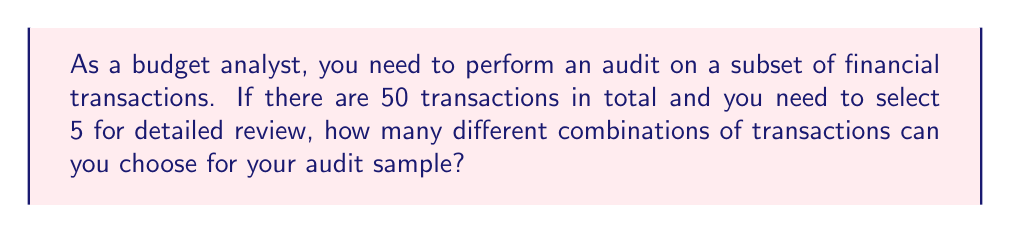Solve this math problem. To solve this problem, we need to use the combination formula. This is because the order of selection doesn't matter (it's not a permutation), and we're selecting a subset from a larger set without replacement.

The combination formula is:

$$C(n,r) = \frac{n!}{r!(n-r)!}$$

Where:
$n$ = total number of items to choose from
$r$ = number of items being chosen

In this case:
$n = 50$ (total transactions)
$r = 5$ (transactions to be audited)

Let's substitute these values:

$$C(50,5) = \frac{50!}{5!(50-5)!} = \frac{50!}{5!45!}$$

Calculating this:

1) $50! = 3.0414 \times 10^{64}$
2) $5! = 120$
3) $45! = 1.1962 \times 10^{56}$

Substituting:

$$\frac{3.0414 \times 10^{64}}{120 \times (1.1962 \times 10^{56})} = 2,118,760$$

Therefore, there are 2,118,760 different possible combinations of 5 transactions that can be selected from a total of 50 transactions for the audit sample.
Answer: 2,118,760 